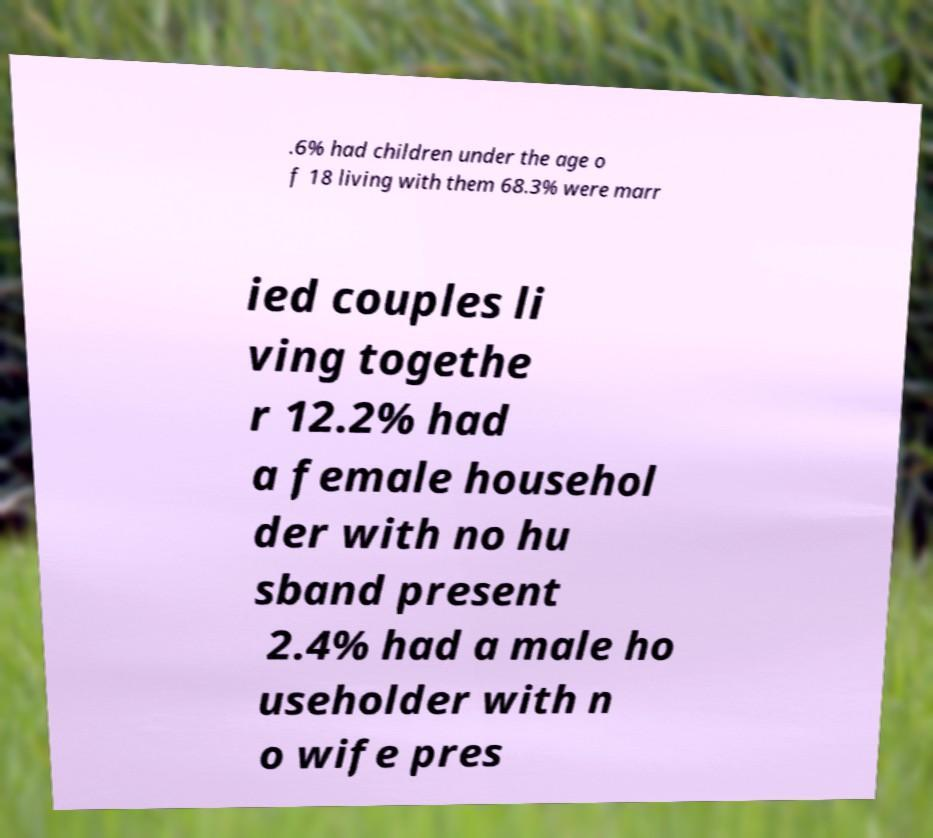Please read and relay the text visible in this image. What does it say? .6% had children under the age o f 18 living with them 68.3% were marr ied couples li ving togethe r 12.2% had a female househol der with no hu sband present 2.4% had a male ho useholder with n o wife pres 